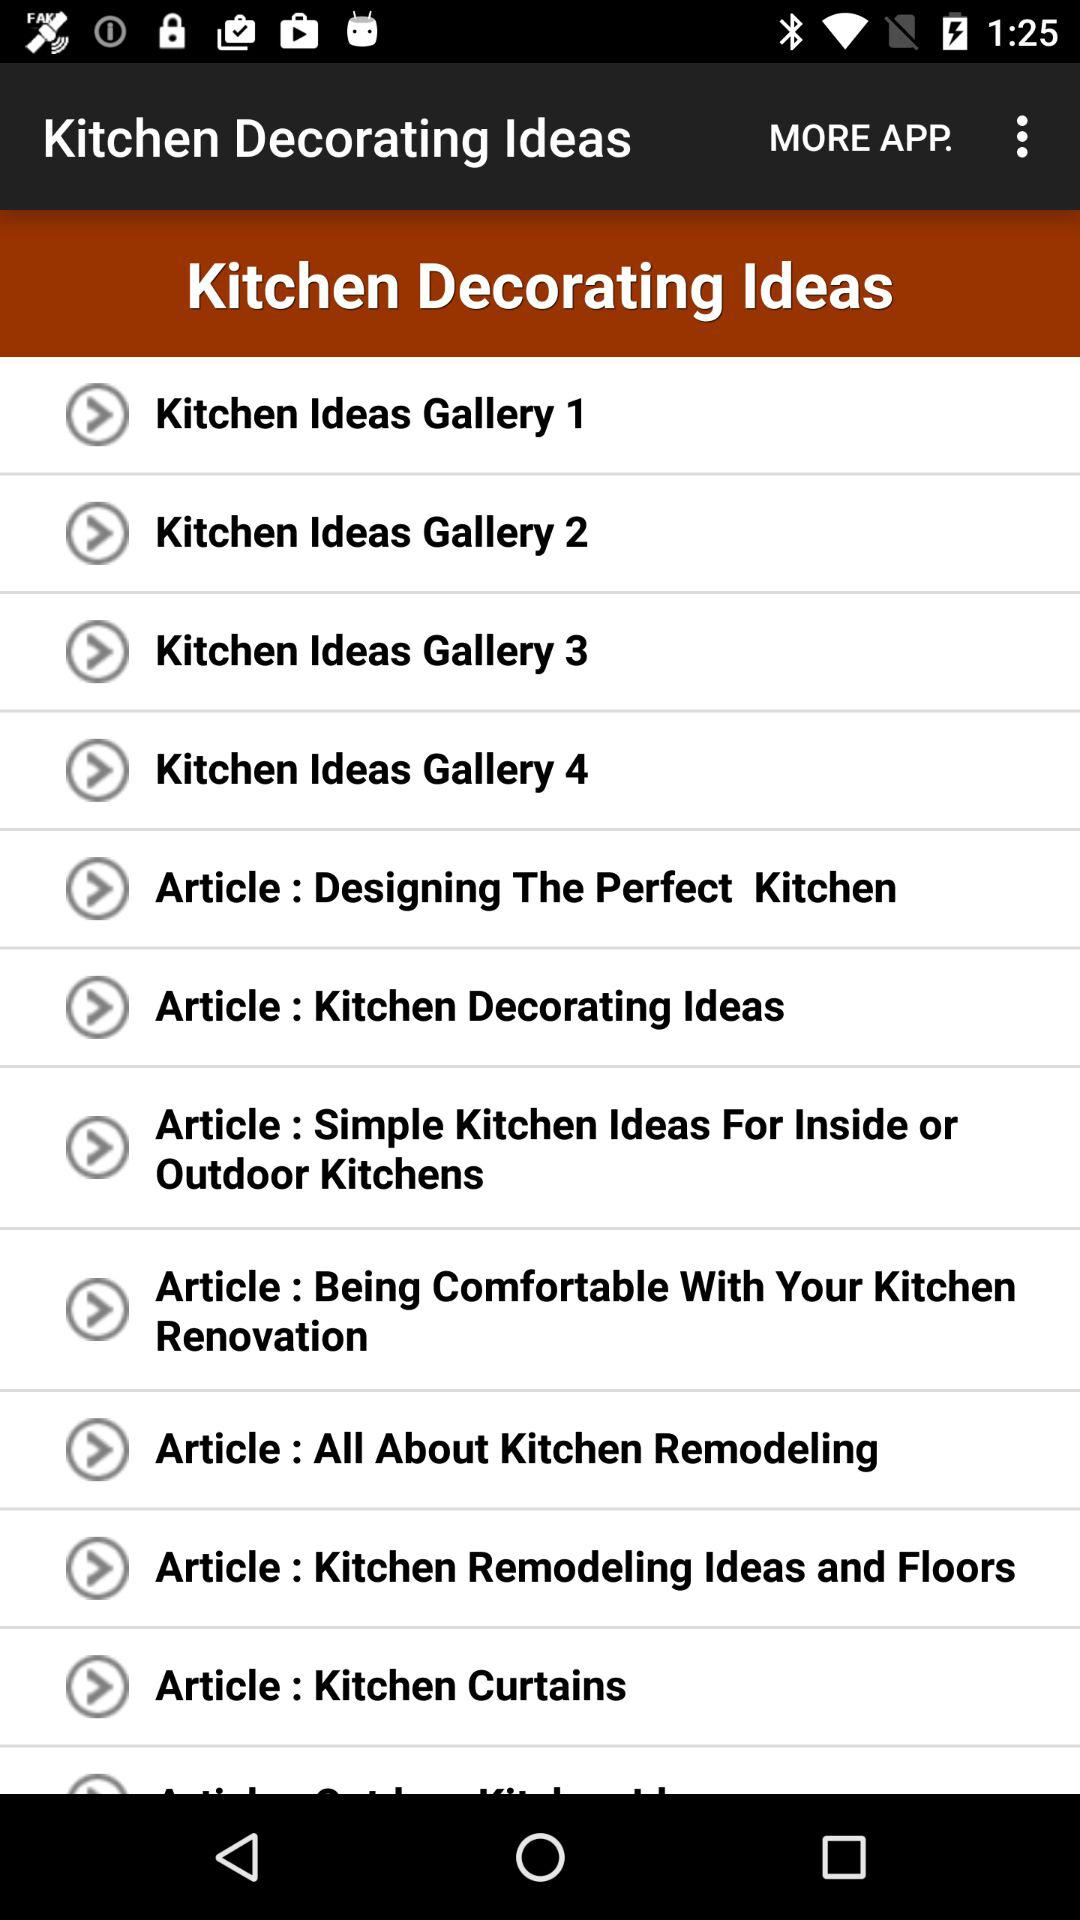How many kitchen ideas galleries are on this page?
Answer the question using a single word or phrase. 4 